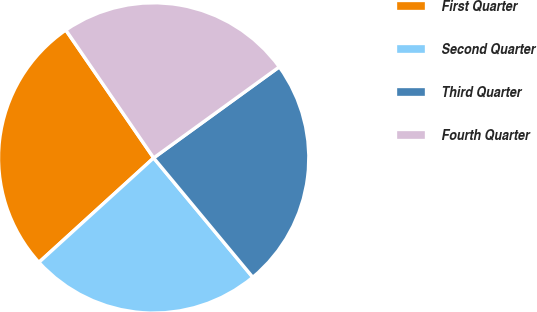<chart> <loc_0><loc_0><loc_500><loc_500><pie_chart><fcel>First Quarter<fcel>Second Quarter<fcel>Third Quarter<fcel>Fourth Quarter<nl><fcel>27.17%<fcel>24.28%<fcel>23.95%<fcel>24.6%<nl></chart> 